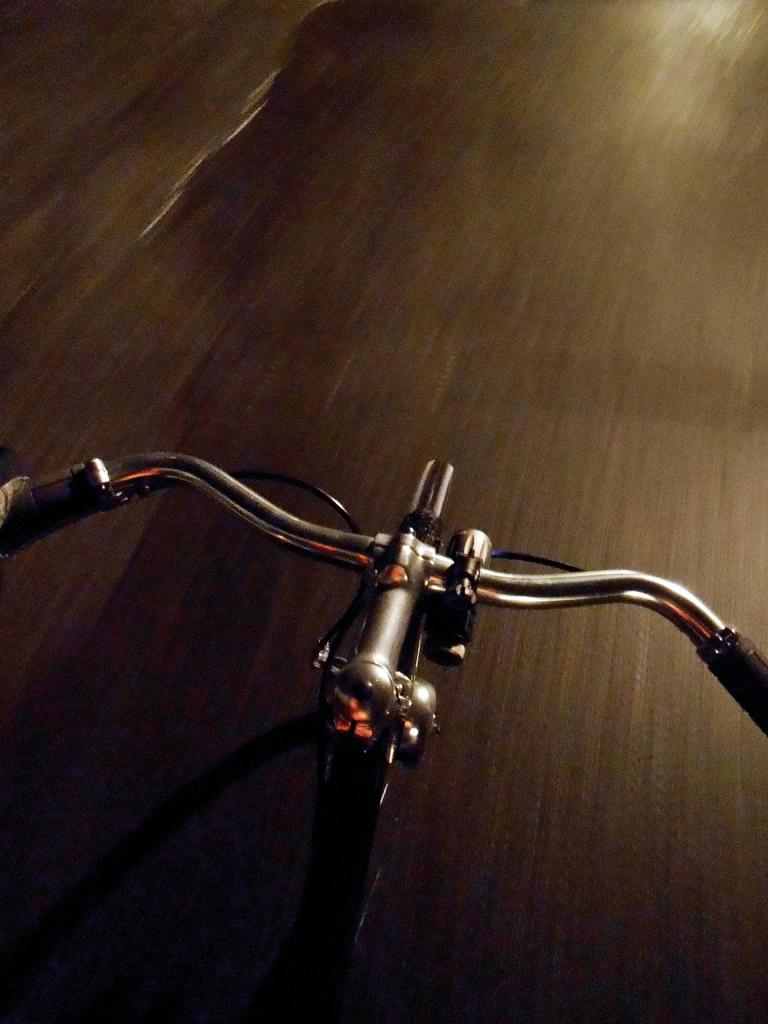What is the main subject of the image? The main subject of the image is a bicycle. Where is the bicycle located? The bicycle is on the road. How many chickens are sitting on the property in the image? There are no chickens or properties present in the image; it features a bicycle on the road. What advice does the father give to the child in the image? There is no child or father present in the image; it only features a bicycle on the road. 